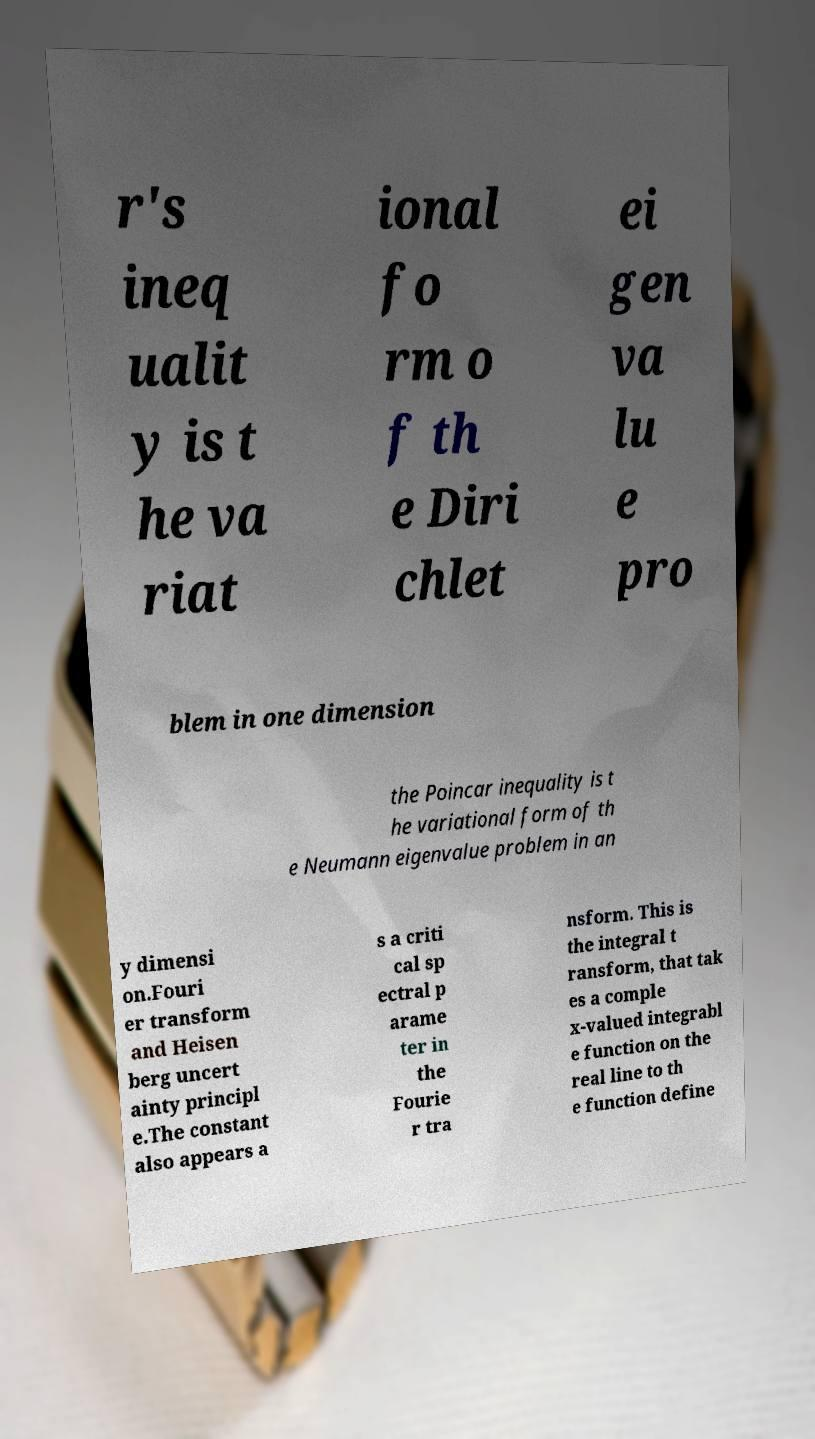Could you extract and type out the text from this image? r's ineq ualit y is t he va riat ional fo rm o f th e Diri chlet ei gen va lu e pro blem in one dimension the Poincar inequality is t he variational form of th e Neumann eigenvalue problem in an y dimensi on.Fouri er transform and Heisen berg uncert ainty principl e.The constant also appears a s a criti cal sp ectral p arame ter in the Fourie r tra nsform. This is the integral t ransform, that tak es a comple x-valued integrabl e function on the real line to th e function define 